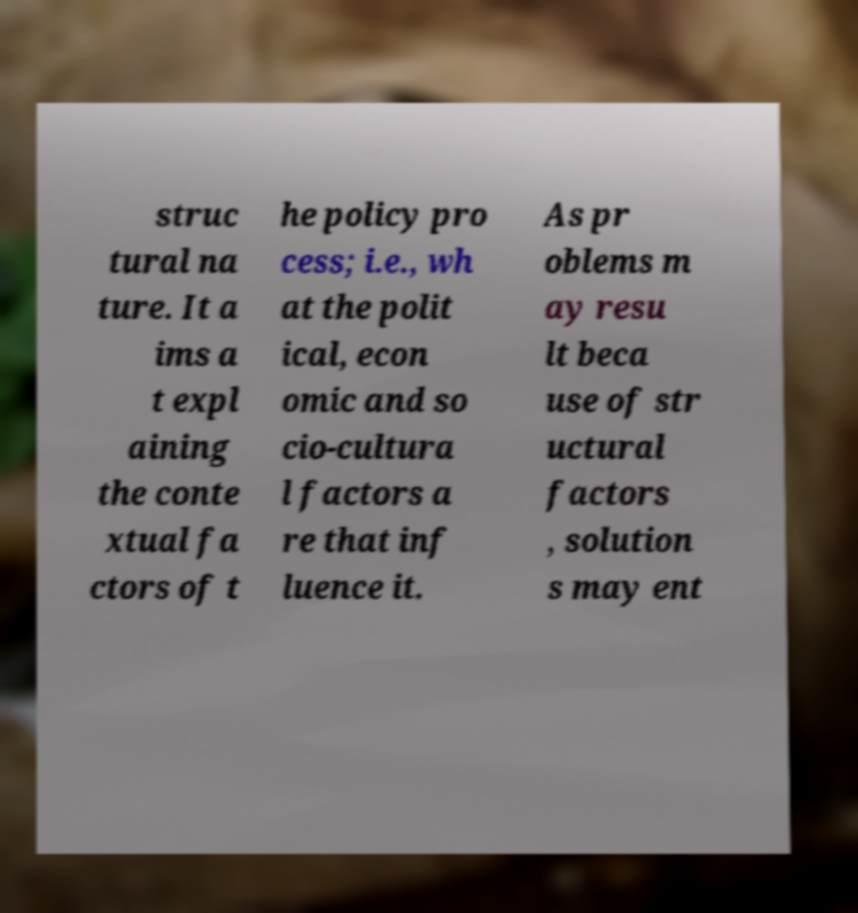Can you accurately transcribe the text from the provided image for me? struc tural na ture. It a ims a t expl aining the conte xtual fa ctors of t he policy pro cess; i.e., wh at the polit ical, econ omic and so cio-cultura l factors a re that inf luence it. As pr oblems m ay resu lt beca use of str uctural factors , solution s may ent 